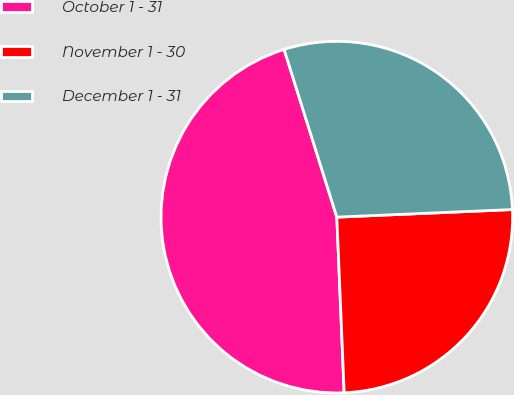Convert chart to OTSL. <chart><loc_0><loc_0><loc_500><loc_500><pie_chart><fcel>October 1 - 31<fcel>November 1 - 30<fcel>December 1 - 31<nl><fcel>45.82%<fcel>25.02%<fcel>29.16%<nl></chart> 